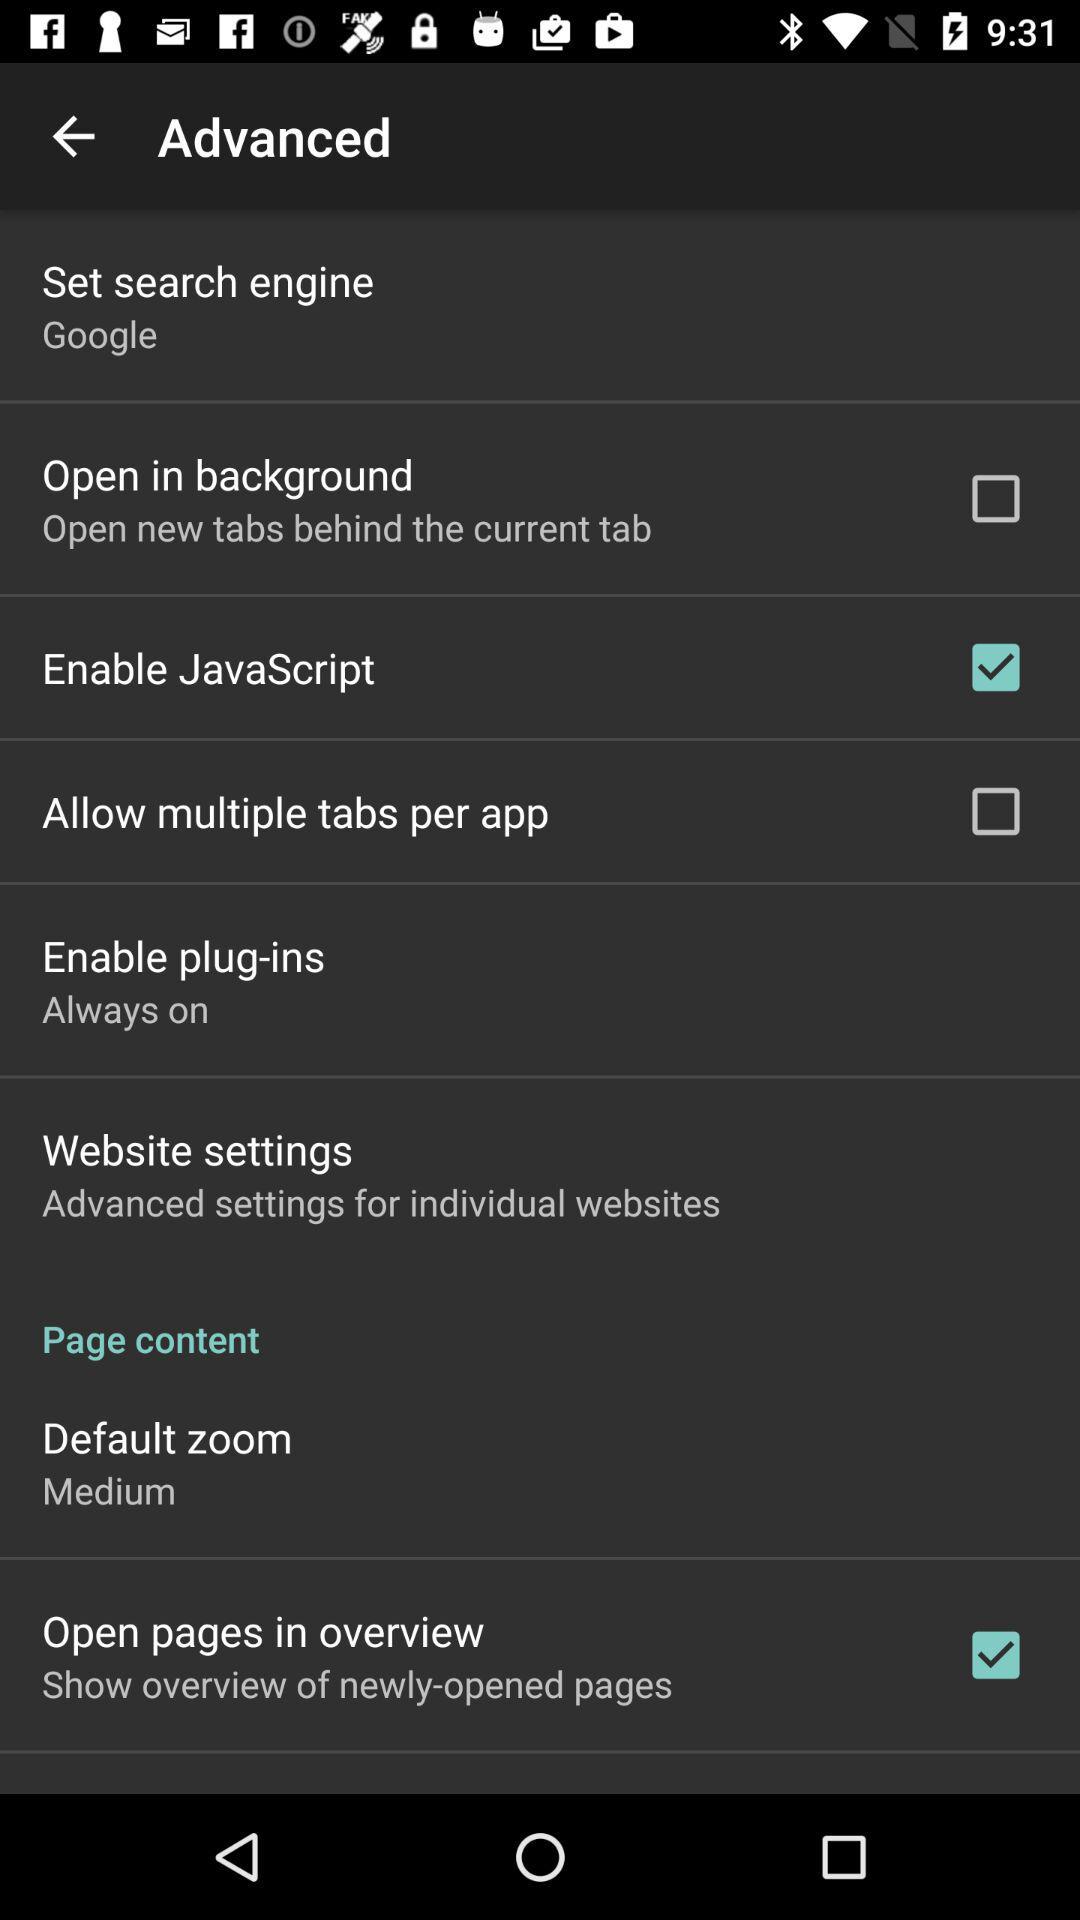What is the status of "Enable JavaScript"? The status is "on". 